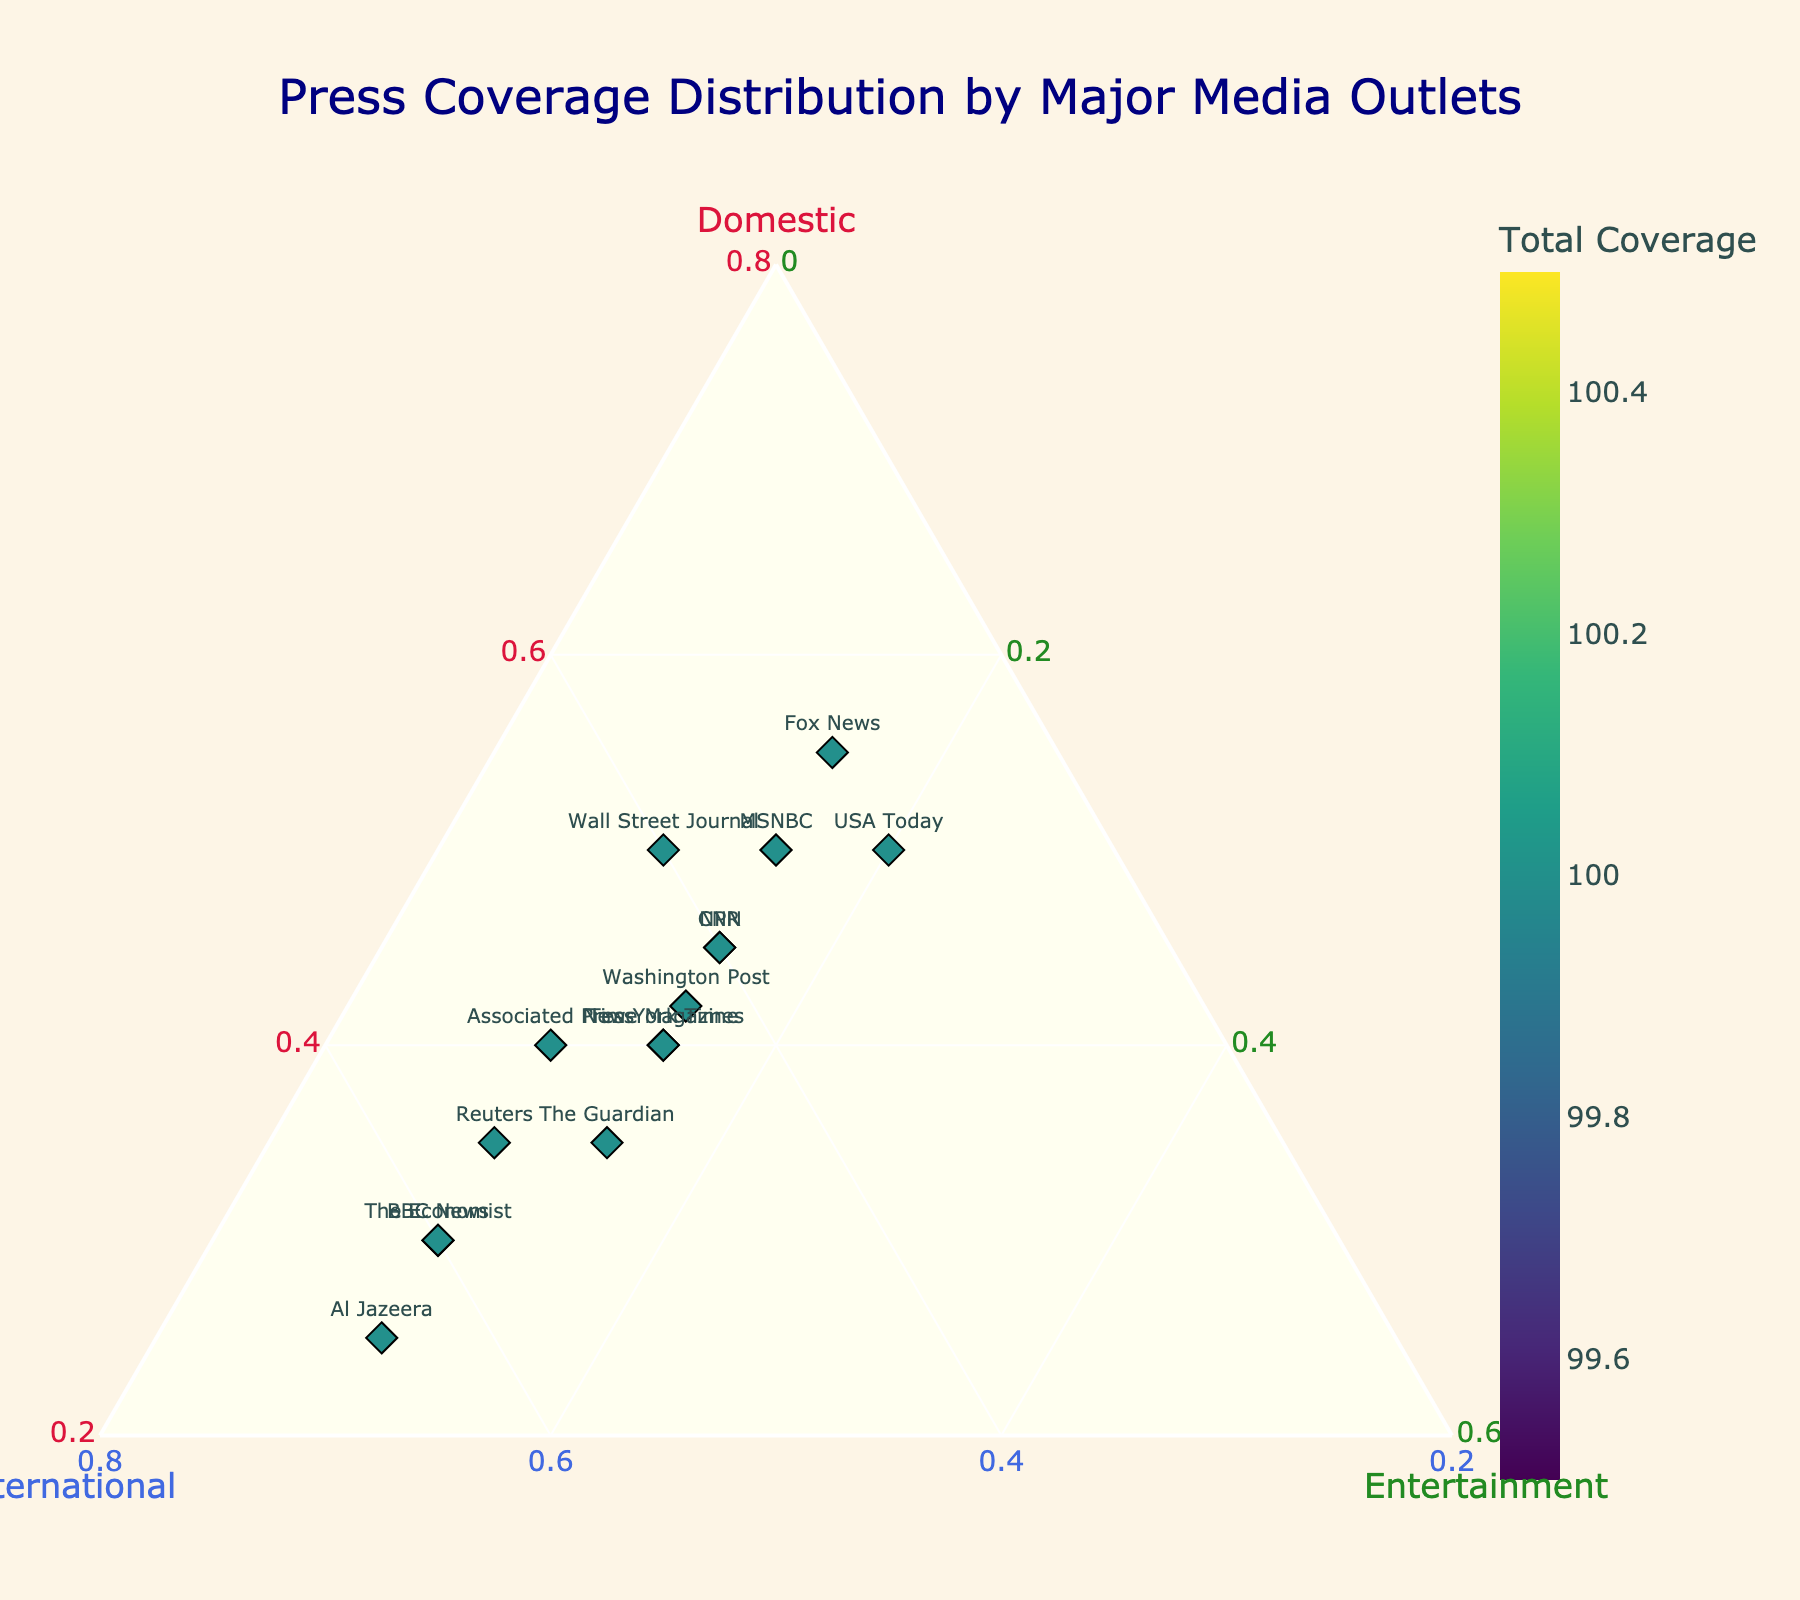Which media outlet has the highest percentage of international coverage? Al Jazeera is positioned farthest along the International axis at 65%, indicating it has the highest percentage of international coverage.
Answer: Al Jazeera Which media outlets have an equal breakdown (similar proportions) of coverage in domestic, international, and entertainment? Outlets such as CNN, NPR, and New York Times have near-equal proportions as they cluster around the center of the ternary plot, each having relatively similar values in domestic, international, and entertainment coverage.
Answer: CNN, NPR, New York Times How many outlets have a proportion of at least 50% domestic coverage? By looking at the Domestic axis, outlets CNN, Fox News, MSNBC, Wall Street Journal and USA Today cross the 50% line.
Answer: 5 Which media outlet balances their coverage most evenly between domestic and international topics? The New York Times, which is positioned closer to the bisecting line between the Domestic and International axes with values close to 50-50.
Answer: New York Times Which media outlet gives the least attention to entertainment? Reuters, BBC News, Al Jazeera, and The Economist all have the lowest entertainment coverage at 10%, represented by their location closest to the Domestic-International edge of the plot.
Answer: Reuters, BBC News, Al Jazeera, The Economist Between Reuters and The Guardian, which has a higher total coverage? In the plot, the color intensity indicates total coverage. Reuters and The Guardian are both around the same color, suggesting they have similar total coverages, but The Guardian might be slightly higher. Verifying data: The Guardian: 100, Reuters: 100. Thus, they're equal.
Answer: Equal What is the overall trend in coverage proportions between domestic and international topics? Most outlets tend to distribute their coverage more heavily between domestic and international topics while giving less coverage to entertainment, indicated by the wider spread along the Domestic and International axes compared to the Entertainment axis.
Answer: More domestic and international, less entertainment Which media outlet has the highest total coverage, indicated by the color intensity? By looking at color intensity in the plot, we can identify which node is darkest. USA Today, Fox News, and Wall Street Journal all show higher color intensity indicating a higher total coverage.
Answer: USA Today, Fox News, Wall Street Journal 